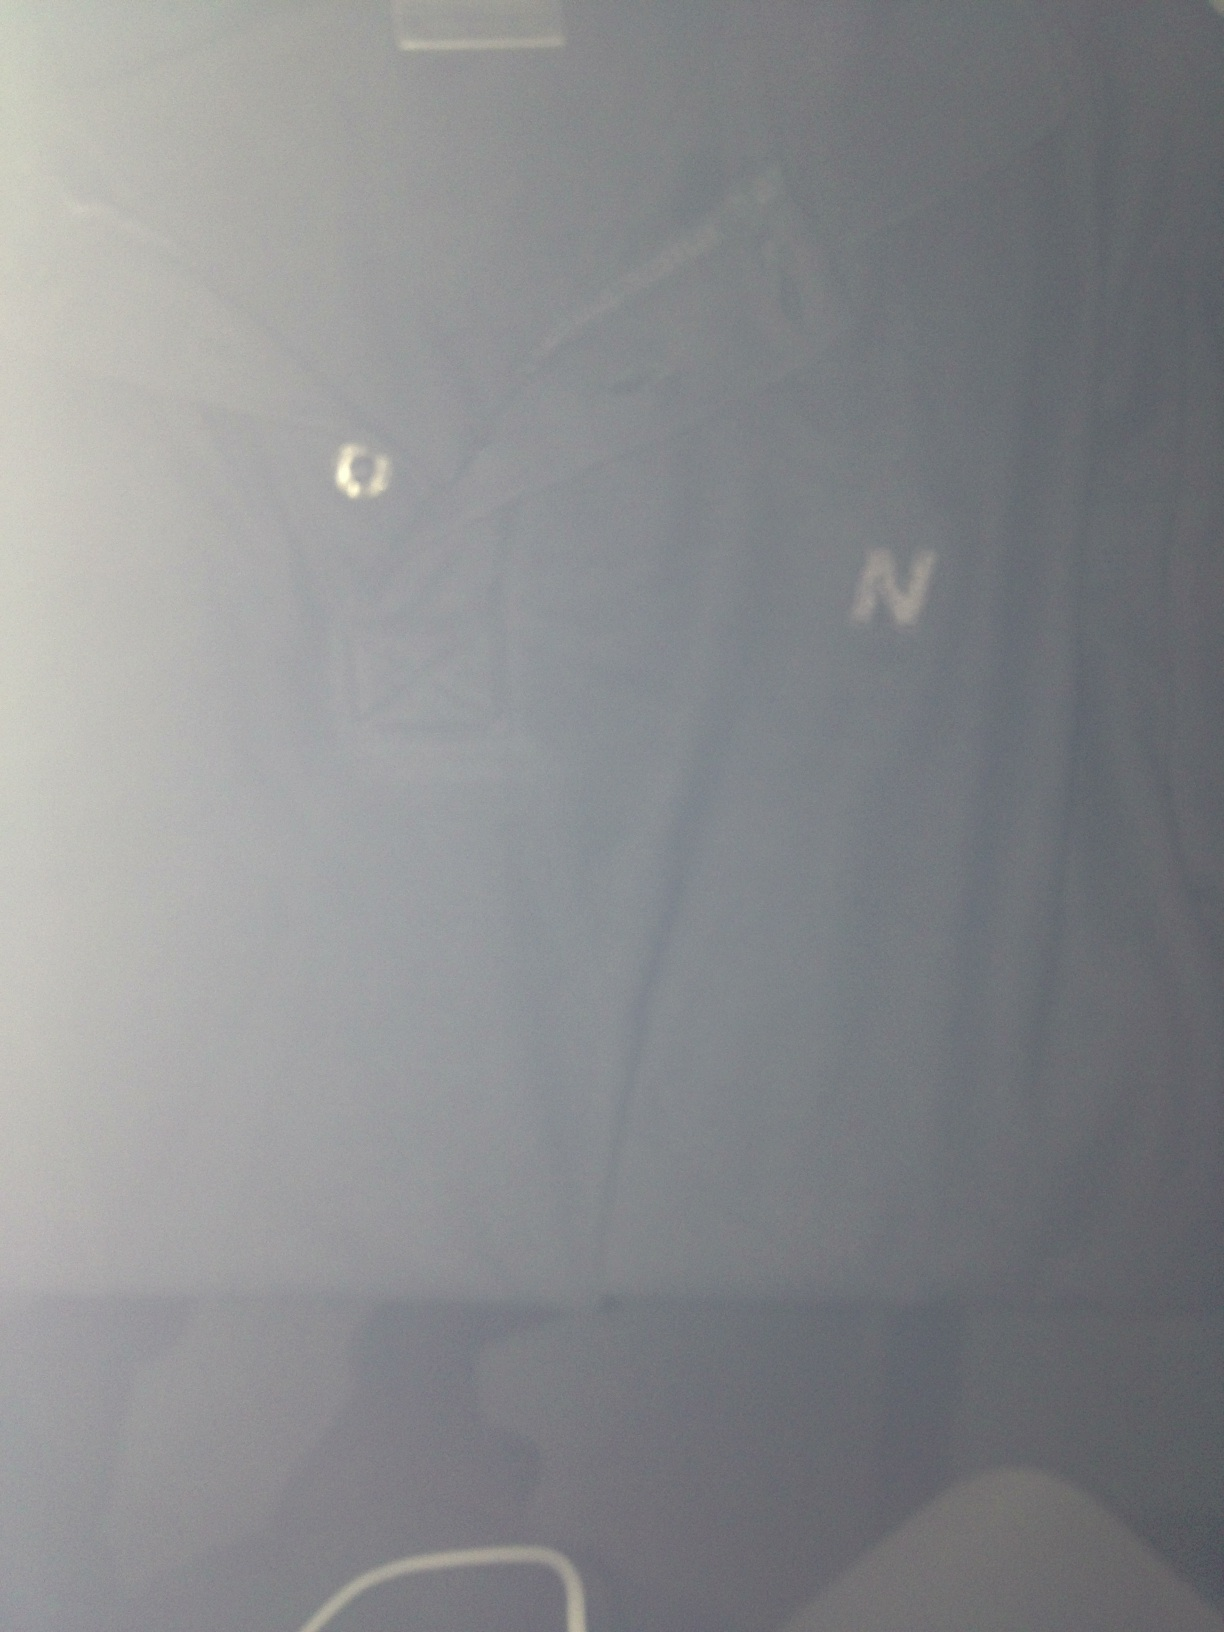Describe a realistic scenario where someone might choose to wear this shirt. A realistic scenario for wearing this shirt could be a casual Friday at the office. With its unique collar and button design, this dark blue tee shirt offers a balance between comfort and presentability. Pairing it with chinos or dark jeans, someone might choose this outfit to maintain a professional yet relaxed appearance, perfect for a productive workday followed by a casual outing with colleagues. 
Another realistic scenario where this shirt could be worn. Another realistic scenario would be wearing this tee shirt for a laid-back weekend brunch with friends. Its comfortable material and cool, dark color make it an excellent choice for a leisurely meal and a stroll around town. Paired with relaxed-fit jeans and sneakers, it provides a stylish yet effortless look. 